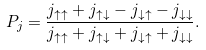<formula> <loc_0><loc_0><loc_500><loc_500>P _ { j } = \frac { j _ { \uparrow \uparrow } + j _ { \uparrow \downarrow } - j _ { \downarrow \uparrow } - j _ { \downarrow \downarrow } } { j _ { \uparrow \uparrow } + j _ { \uparrow \downarrow } + j _ { \downarrow \uparrow } + j _ { \downarrow \downarrow } } .</formula> 